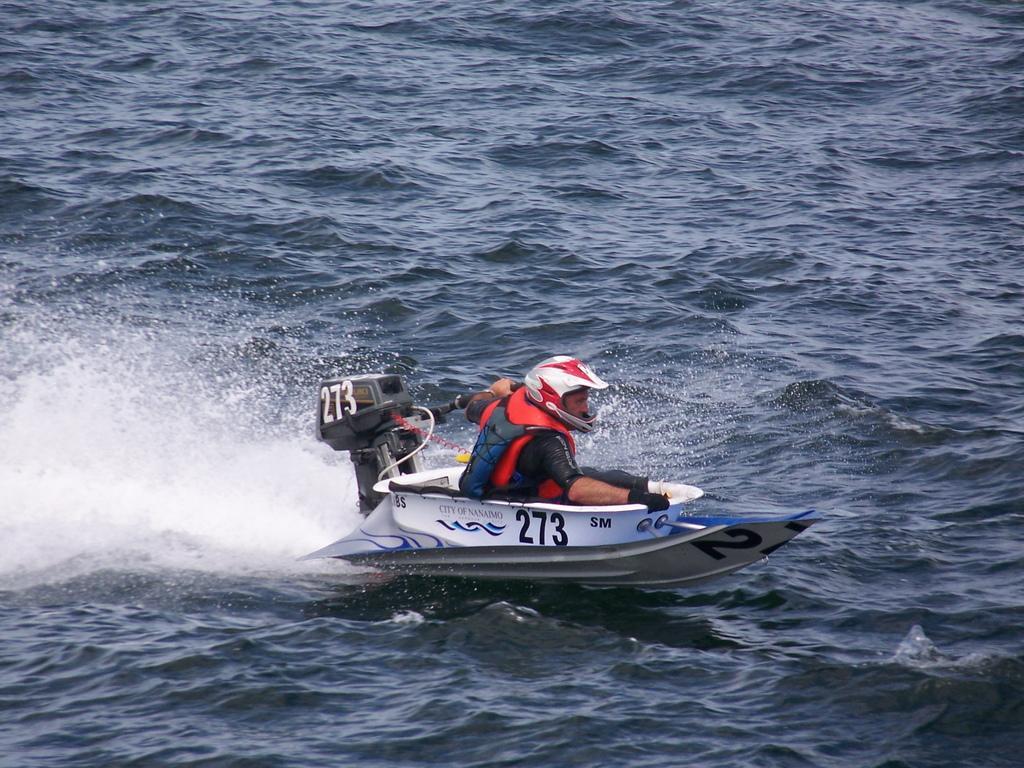Can you describe this image briefly? In this image I can see the person with the speed boat. I can see the person wearing the dress and helmet. The boat is on the water. 